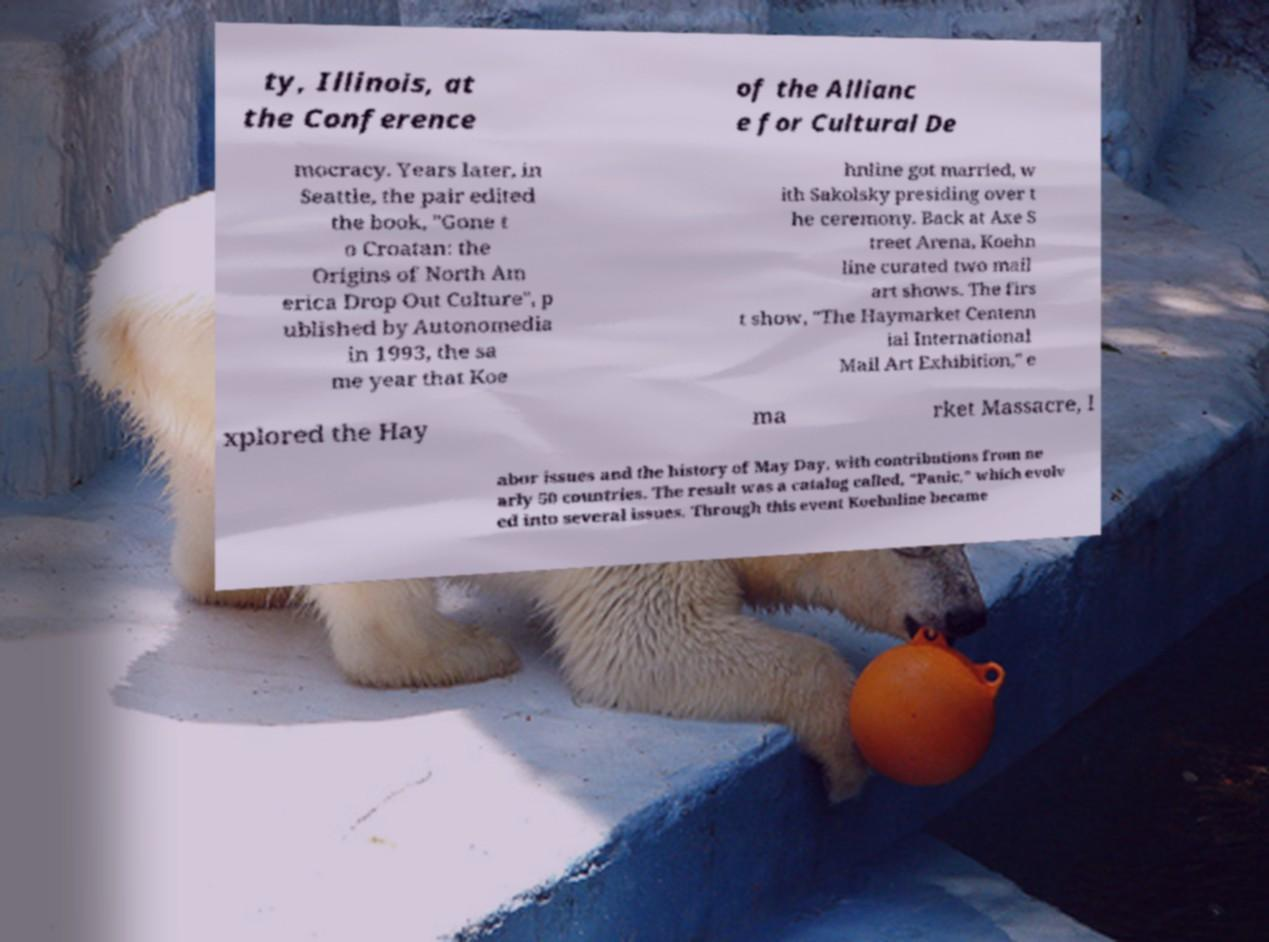I need the written content from this picture converted into text. Can you do that? ty, Illinois, at the Conference of the Allianc e for Cultural De mocracy. Years later, in Seattle, the pair edited the book, "Gone t o Croatan: the Origins of North Am erica Drop Out Culture", p ublished by Autonomedia in 1993, the sa me year that Koe hnline got married, w ith Sakolsky presiding over t he ceremony. Back at Axe S treet Arena, Koehn line curated two mail art shows. The firs t show, "The Haymarket Centenn ial International Mail Art Exhibition," e xplored the Hay ma rket Massacre, l abor issues and the history of May Day, with contributions from ne arly 50 countries. The result was a catalog called, "Panic," which evolv ed into several issues. Through this event Koehnline became 